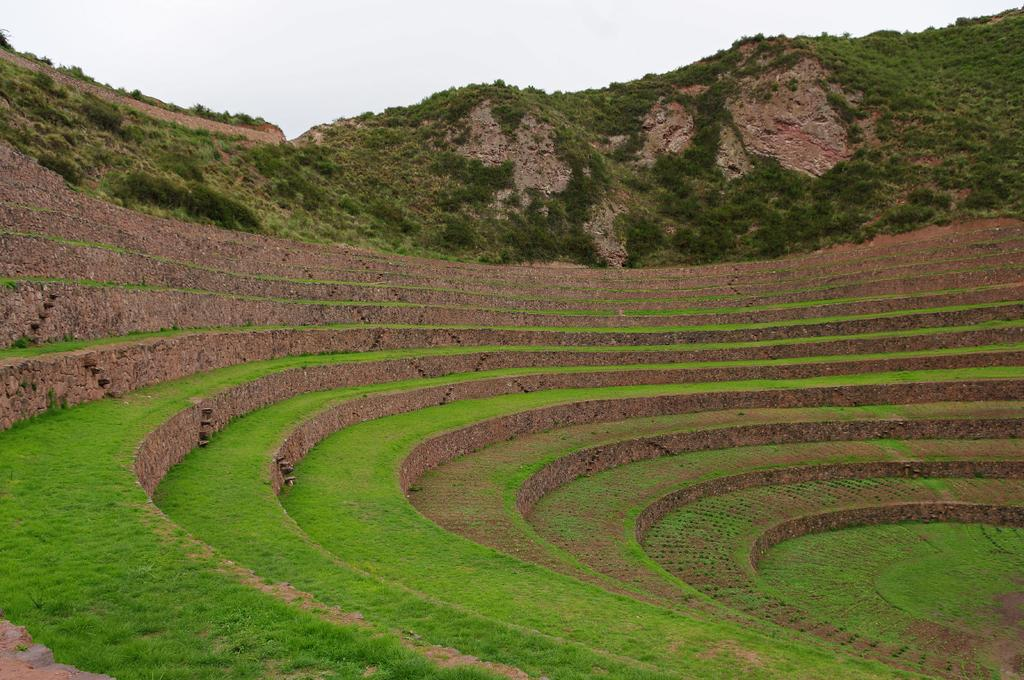What type of stadium is shown in the image? There is a mud stadium in the image. What is the condition of the stadium's surface? The mud stadium has some grass on it. What can be seen in the background of the image? There is a mountain visible in the background of the image. How is the mountain covered? The mountain has many trees on it. Can you tell me how many goats are grazing on the mountain in the image? There are no goats visible in the image; the mountain is covered with trees. What type of development can be seen near the mud stadium in the image? There is no development visible near the mud stadium in the image; it is surrounded by grass and trees. 